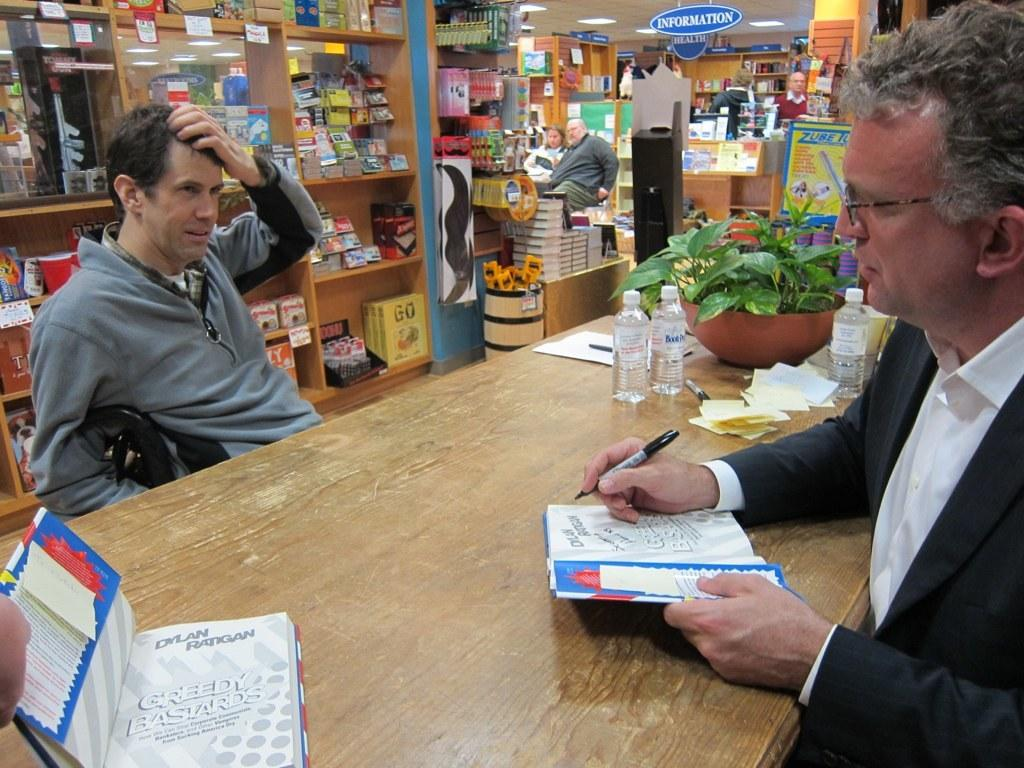<image>
Create a compact narrative representing the image presented. A man is signing a book called Greedy Bastards by Dylan Ratgan. 